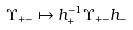Convert formula to latex. <formula><loc_0><loc_0><loc_500><loc_500>\Upsilon _ { + - } \mapsto h _ { + } ^ { - 1 } \Upsilon _ { + - } h _ { - }</formula> 